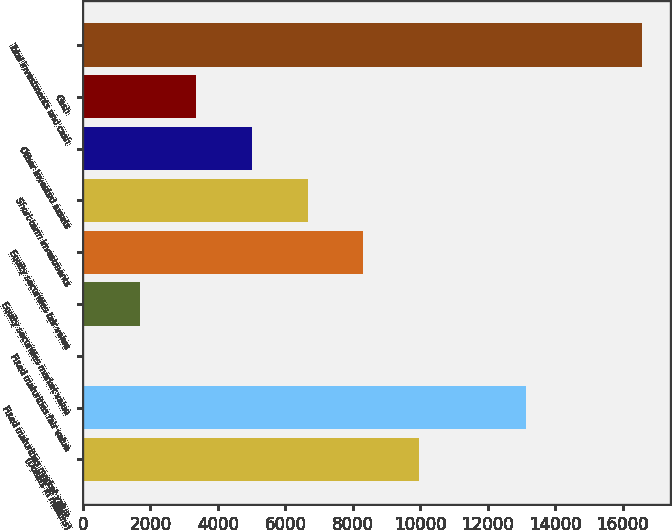<chart> <loc_0><loc_0><loc_500><loc_500><bar_chart><fcel>(Dollars in millions)<fcel>Fixed maturities market value<fcel>Fixed maturities fair value<fcel>Equity securities market value<fcel>Equity securities fair value<fcel>Short-term investments<fcel>Other invested assets<fcel>Cash<fcel>Total investments and cash<nl><fcel>9962.32<fcel>13141.7<fcel>41.5<fcel>1694.97<fcel>8308.85<fcel>6655.38<fcel>5001.91<fcel>3348.44<fcel>16576.2<nl></chart> 